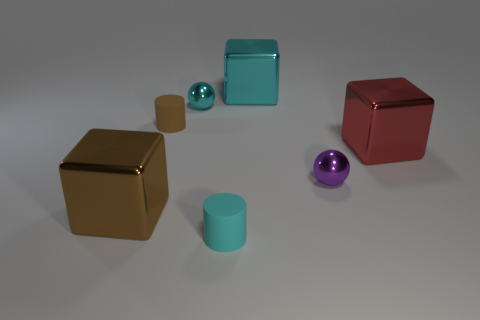There is a rubber thing that is in front of the purple sphere; what is its size?
Keep it short and to the point. Small. Is there a large cyan block made of the same material as the red thing?
Offer a very short reply. Yes. How many tiny cyan objects have the same shape as the big cyan metallic thing?
Your response must be concise. 0. The tiny cyan object in front of the cube left of the tiny object that is in front of the large brown shiny block is what shape?
Give a very brief answer. Cylinder. The small object that is both in front of the red cube and left of the cyan metal block is made of what material?
Give a very brief answer. Rubber. There is a matte object in front of the purple object; is it the same size as the tiny brown rubber cylinder?
Provide a short and direct response. Yes. Are there more large cyan metal objects behind the big brown thing than metal spheres that are left of the brown cylinder?
Offer a terse response. Yes. What color is the tiny cylinder in front of the red metal thing behind the brown thing on the left side of the tiny brown cylinder?
Your answer should be very brief. Cyan. How many objects are either brown metal objects or large red rubber balls?
Provide a short and direct response. 1. How many things are either brown cubes or cubes that are behind the red thing?
Make the answer very short. 2. 